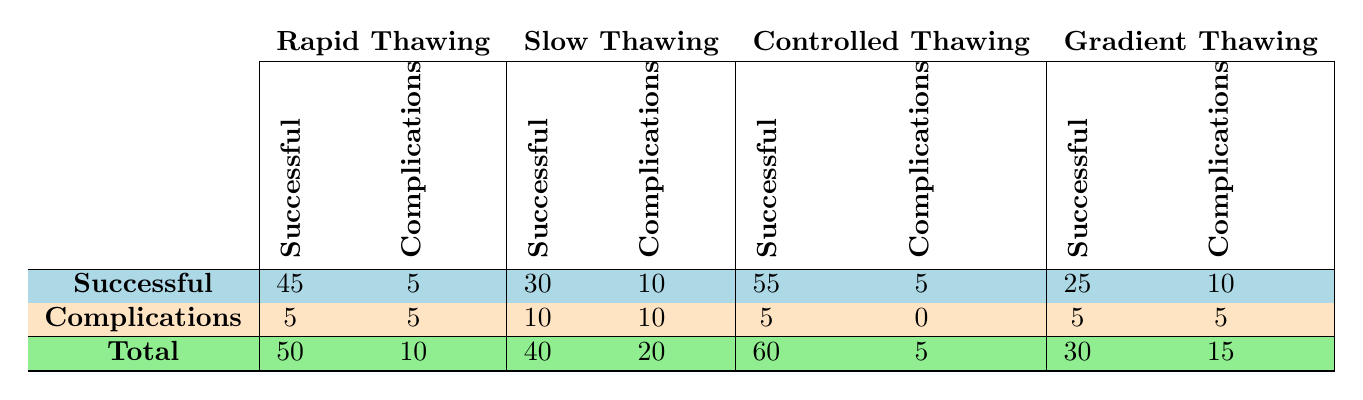What is the total number of successful recoveries for the Rapid Thawing protocol? The total number of successful recoveries for the Rapid Thawing protocol is shown directly in the table as 50.
Answer: 50 Which thawing protocol led to the highest number of complications? By observing the table, the Slow Thawing protocol had the highest number of complications listed at 20.
Answer: Slow Thawing What is the difference in successful recoveries between Controlled Thawing and Gradient Thawing? The successful recoveries for Controlled Thawing are 60, while for Gradient Thawing they are 30. The difference is calculated as 60 - 30 = 30.
Answer: 30 Did the Rapid Thawing protocol have more successful recoveries than complications? Yes, Rapid Thawing had 50 successful recoveries and only 10 complications, confirming that successful recoveries exceed complications.
Answer: Yes What is the average number of successful recoveries across all thawing protocols? Summing the successful recoveries: (50 + 40 + 60 + 30) = 180. There are 4 protocols, so the average is 180 / 4 = 45.
Answer: 45 Which protocol had the least amount of complications, and what was the number? From the table, the Controlled Thawing protocol had the least complications, which is 5.
Answer: Controlled Thawing, 5 If you add the successful recoveries for Slow and Gradient Thawing, how many do you get? Adding successful recoveries for Slow Thawing (40) and Gradient Thawing (30) gives us a total of 40 + 30 = 70.
Answer: 70 Is it true that Controlled Thawing had more successful recoveries than Rapid Thawing? No, Controlled Thawing had 60 successful recoveries while Rapid Thawing had 50, thus Controlled Thawing had more.
Answer: Yes What percentage of complications occurred during Gradient Thawing compared to the total complications across all protocols? The total complications are (10 + 20 + 5 + 15) = 50. Gradient Thawing had 15 complications, which is (15 / 50) * 100% = 30%.
Answer: 30% 